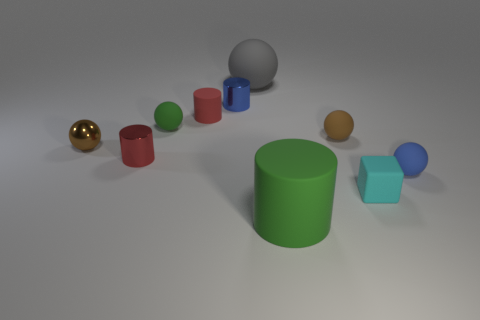Subtract all brown rubber spheres. How many spheres are left? 4 Subtract all yellow balls. Subtract all cyan cylinders. How many balls are left? 5 Subtract all cubes. How many objects are left? 9 Subtract all yellow matte cylinders. Subtract all blue balls. How many objects are left? 9 Add 5 small blue cylinders. How many small blue cylinders are left? 6 Add 5 big yellow spheres. How many big yellow spheres exist? 5 Subtract 0 yellow balls. How many objects are left? 10 